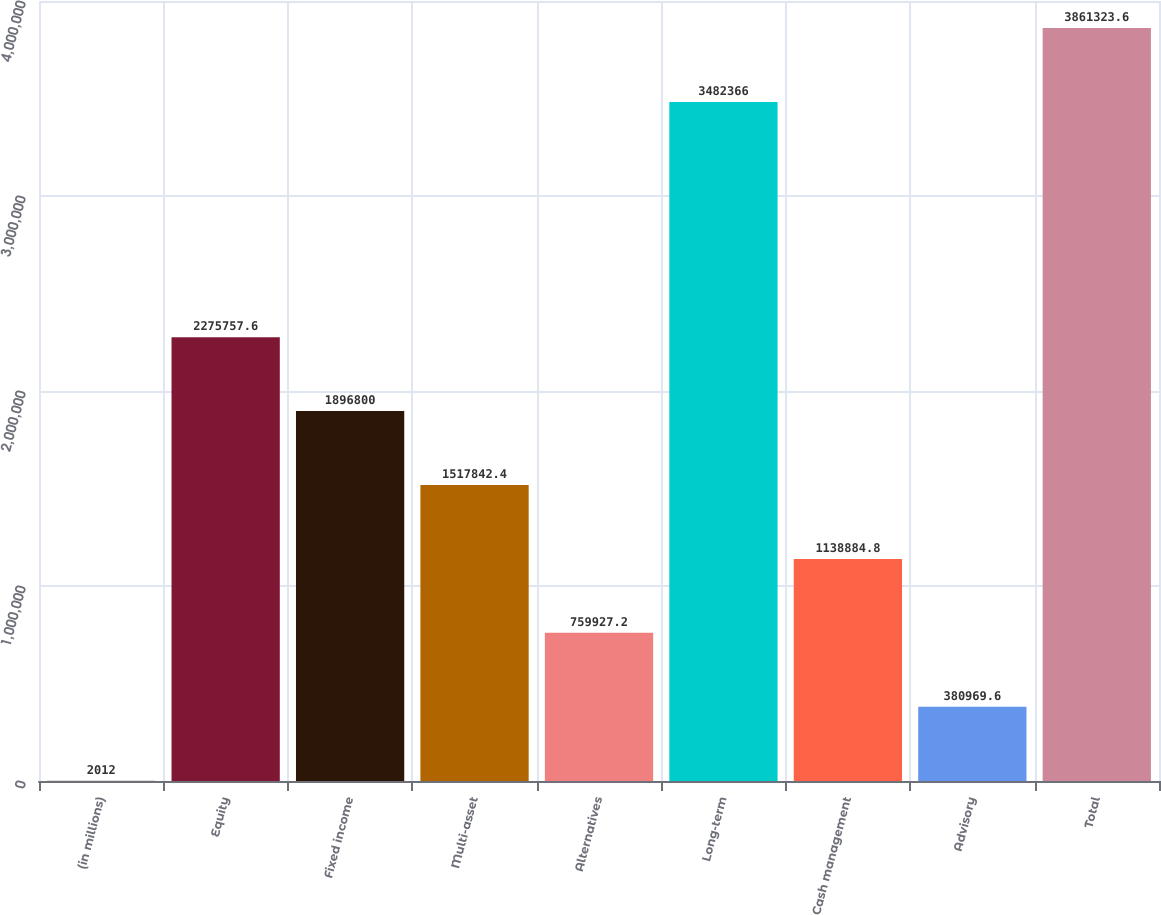Convert chart. <chart><loc_0><loc_0><loc_500><loc_500><bar_chart><fcel>(in millions)<fcel>Equity<fcel>Fixed income<fcel>Multi-asset<fcel>Alternatives<fcel>Long-term<fcel>Cash management<fcel>Advisory<fcel>Total<nl><fcel>2012<fcel>2.27576e+06<fcel>1.8968e+06<fcel>1.51784e+06<fcel>759927<fcel>3.48237e+06<fcel>1.13888e+06<fcel>380970<fcel>3.86132e+06<nl></chart> 